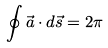<formula> <loc_0><loc_0><loc_500><loc_500>\oint \vec { a } \cdot d \vec { s } = 2 \pi</formula> 